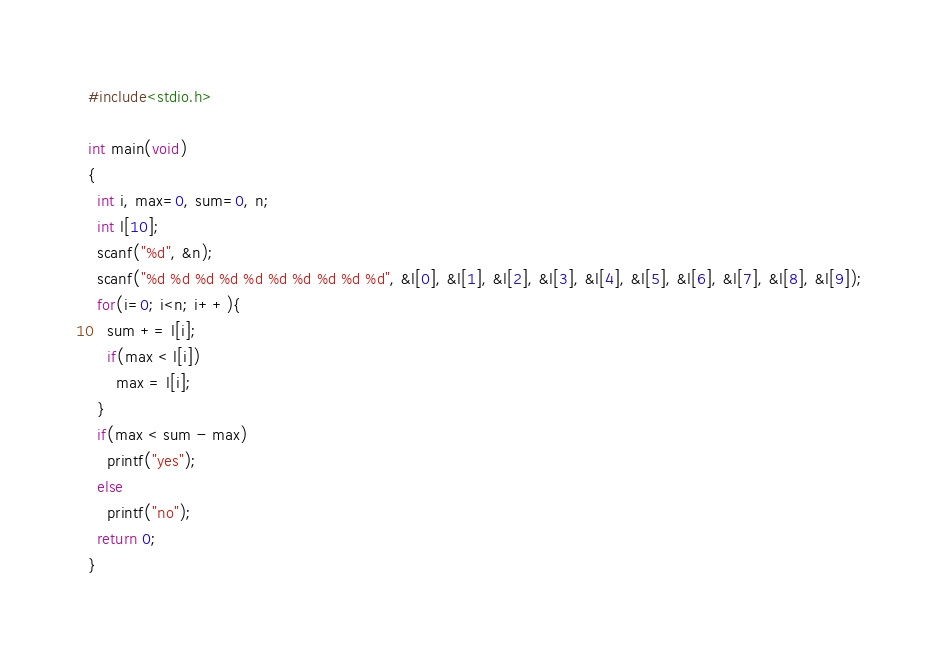<code> <loc_0><loc_0><loc_500><loc_500><_C_>#include<stdio.h>
 
int main(void)
{
  int i, max=0, sum=0, n;
  int l[10];
  scanf("%d", &n);
  scanf("%d %d %d %d %d %d %d %d %d %d", &l[0], &l[1], &l[2], &l[3], &l[4], &l[5], &l[6], &l[7], &l[8], &l[9]);
  for(i=0; i<n; i++){
    sum += l[i];
    if(max < l[i])
      max = l[i];
  }
  if(max < sum - max)
    printf("yes");
  else
    printf("no");
  return 0;
}</code> 